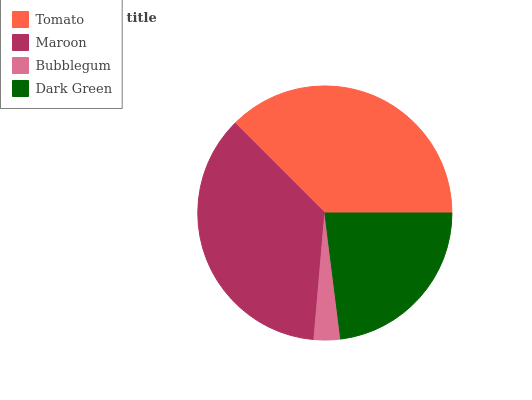Is Bubblegum the minimum?
Answer yes or no. Yes. Is Tomato the maximum?
Answer yes or no. Yes. Is Maroon the minimum?
Answer yes or no. No. Is Maroon the maximum?
Answer yes or no. No. Is Tomato greater than Maroon?
Answer yes or no. Yes. Is Maroon less than Tomato?
Answer yes or no. Yes. Is Maroon greater than Tomato?
Answer yes or no. No. Is Tomato less than Maroon?
Answer yes or no. No. Is Maroon the high median?
Answer yes or no. Yes. Is Dark Green the low median?
Answer yes or no. Yes. Is Dark Green the high median?
Answer yes or no. No. Is Bubblegum the low median?
Answer yes or no. No. 